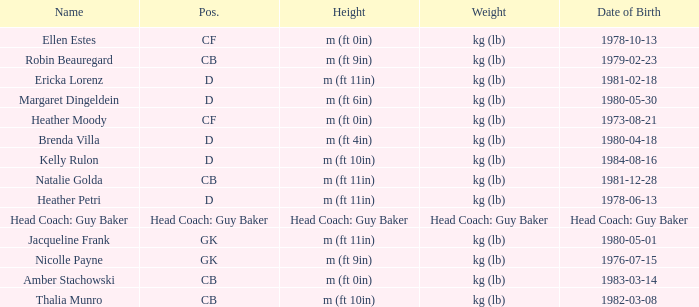Born on 1973-08-21, what is the cf's name? Heather Moody. 